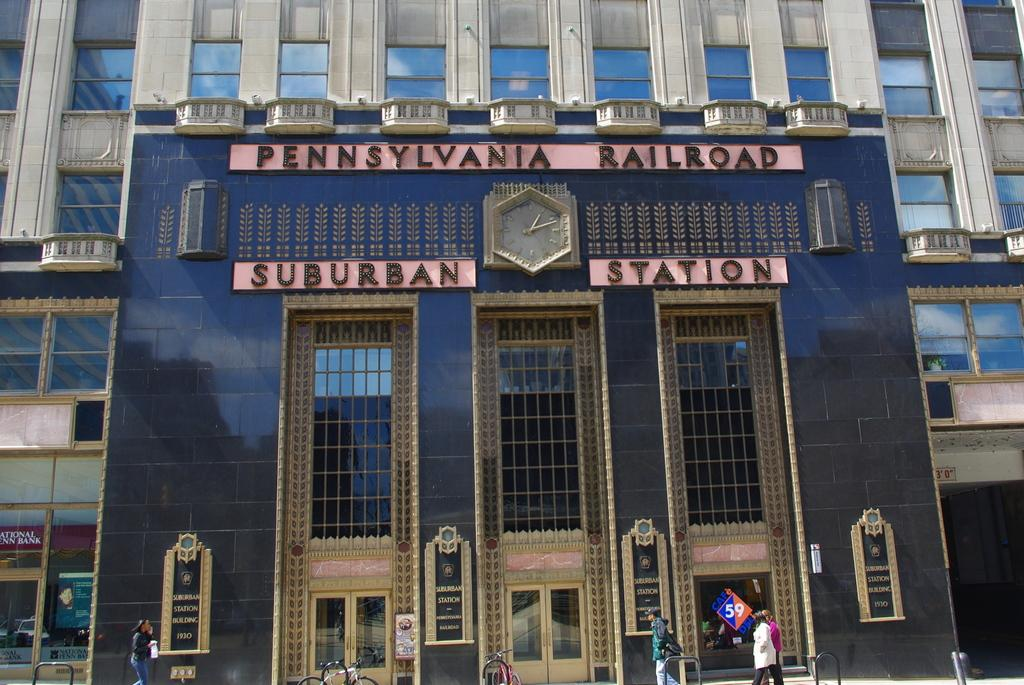What type of structure is visible in the image? There is a building in the image. What can be seen on the walls of the building? There is text on the walls of the building. What are the people in the image doing? There are people walking in the image. What mode of transportation can be seen parked in the image? There are bicycles parked in the image. What type of vegetable is being used as a decoration on the building in the image? There is no vegetable being used as a decoration on the building in the image. 